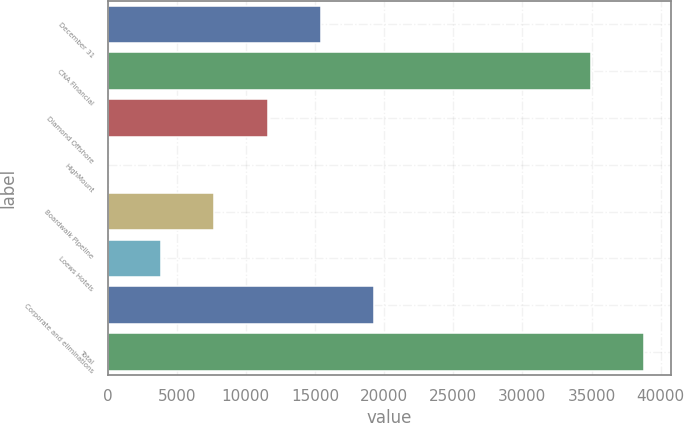Convert chart. <chart><loc_0><loc_0><loc_500><loc_500><bar_chart><fcel>December 31<fcel>CNA Financial<fcel>Diamond Offshore<fcel>HighMount<fcel>Boardwalk Pipeline<fcel>Loews Hotels<fcel>Corporate and eliminations<fcel>Total<nl><fcel>15407.6<fcel>34980<fcel>11567.2<fcel>46<fcel>7726.8<fcel>3886.4<fcel>19248<fcel>38820.4<nl></chart> 